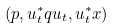<formula> <loc_0><loc_0><loc_500><loc_500>\left ( p , u _ { t } ^ { \ast } q u _ { t } , u _ { t } ^ { \ast } x \right )</formula> 